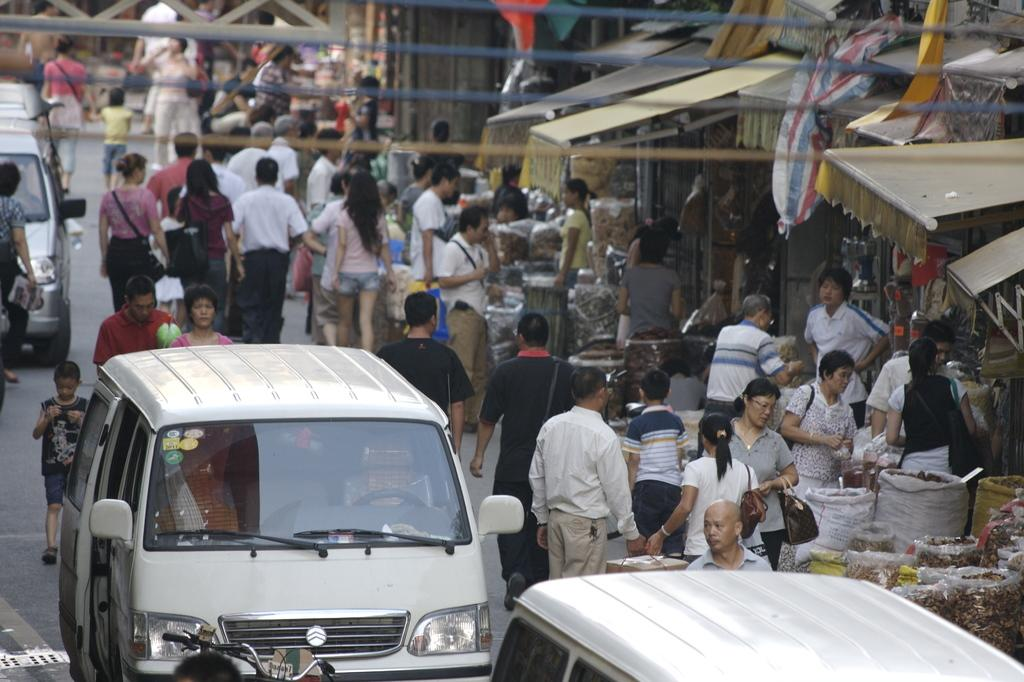What can be seen on the road in the image? There are vehicles, a group of people, and stalls on the road. What are the vehicles doing on the road? The vehicles are likely moving or parked on the road. What might the group of people be doing on the road? The group of people might be walking, shopping, or interacting with the stalls. What type of establishments are represented by the stalls on the road? The stalls on the road might be selling food, drinks, or other goods. What type of bun is being used to hold up the vest in the image? There is no bun or vest present in the image; it features vehicles, a group of people, and stalls on the road. What scene is depicted in the background of the image? The provided facts do not mention a background scene; the image focuses on the road and its contents. 